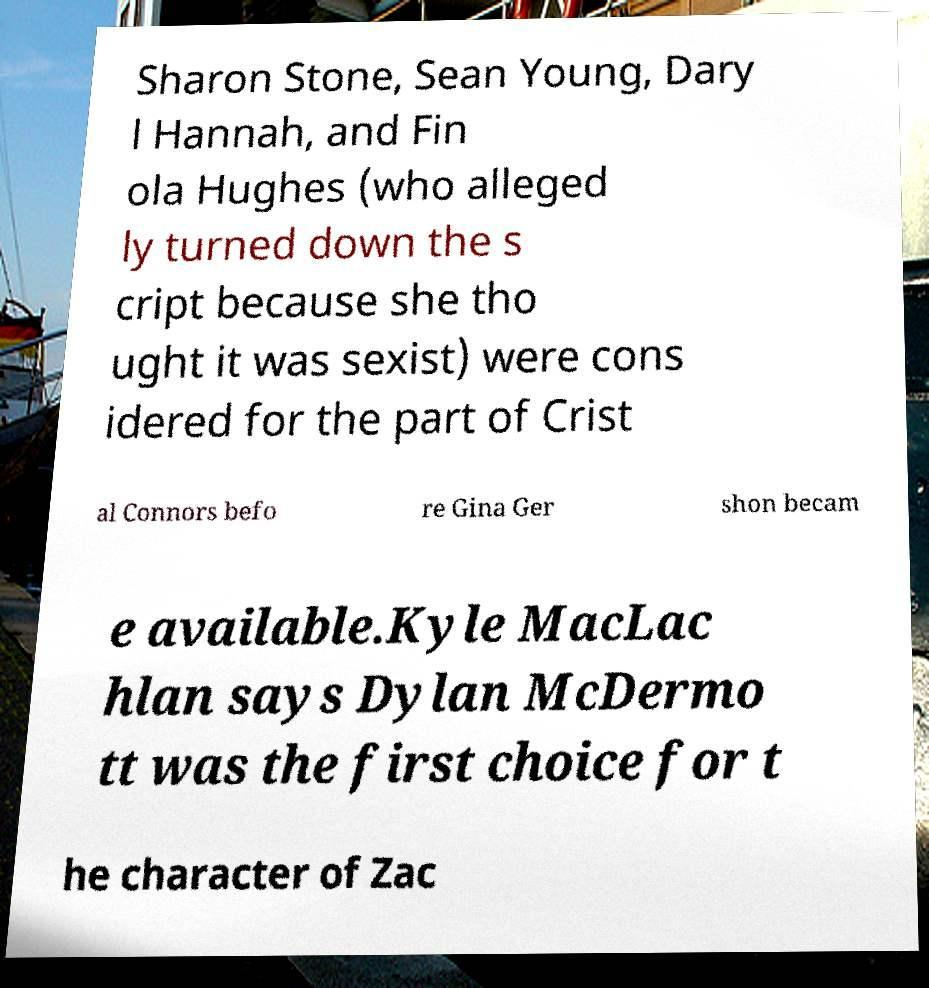Could you assist in decoding the text presented in this image and type it out clearly? Sharon Stone, Sean Young, Dary l Hannah, and Fin ola Hughes (who alleged ly turned down the s cript because she tho ught it was sexist) were cons idered for the part of Crist al Connors befo re Gina Ger shon becam e available.Kyle MacLac hlan says Dylan McDermo tt was the first choice for t he character of Zac 